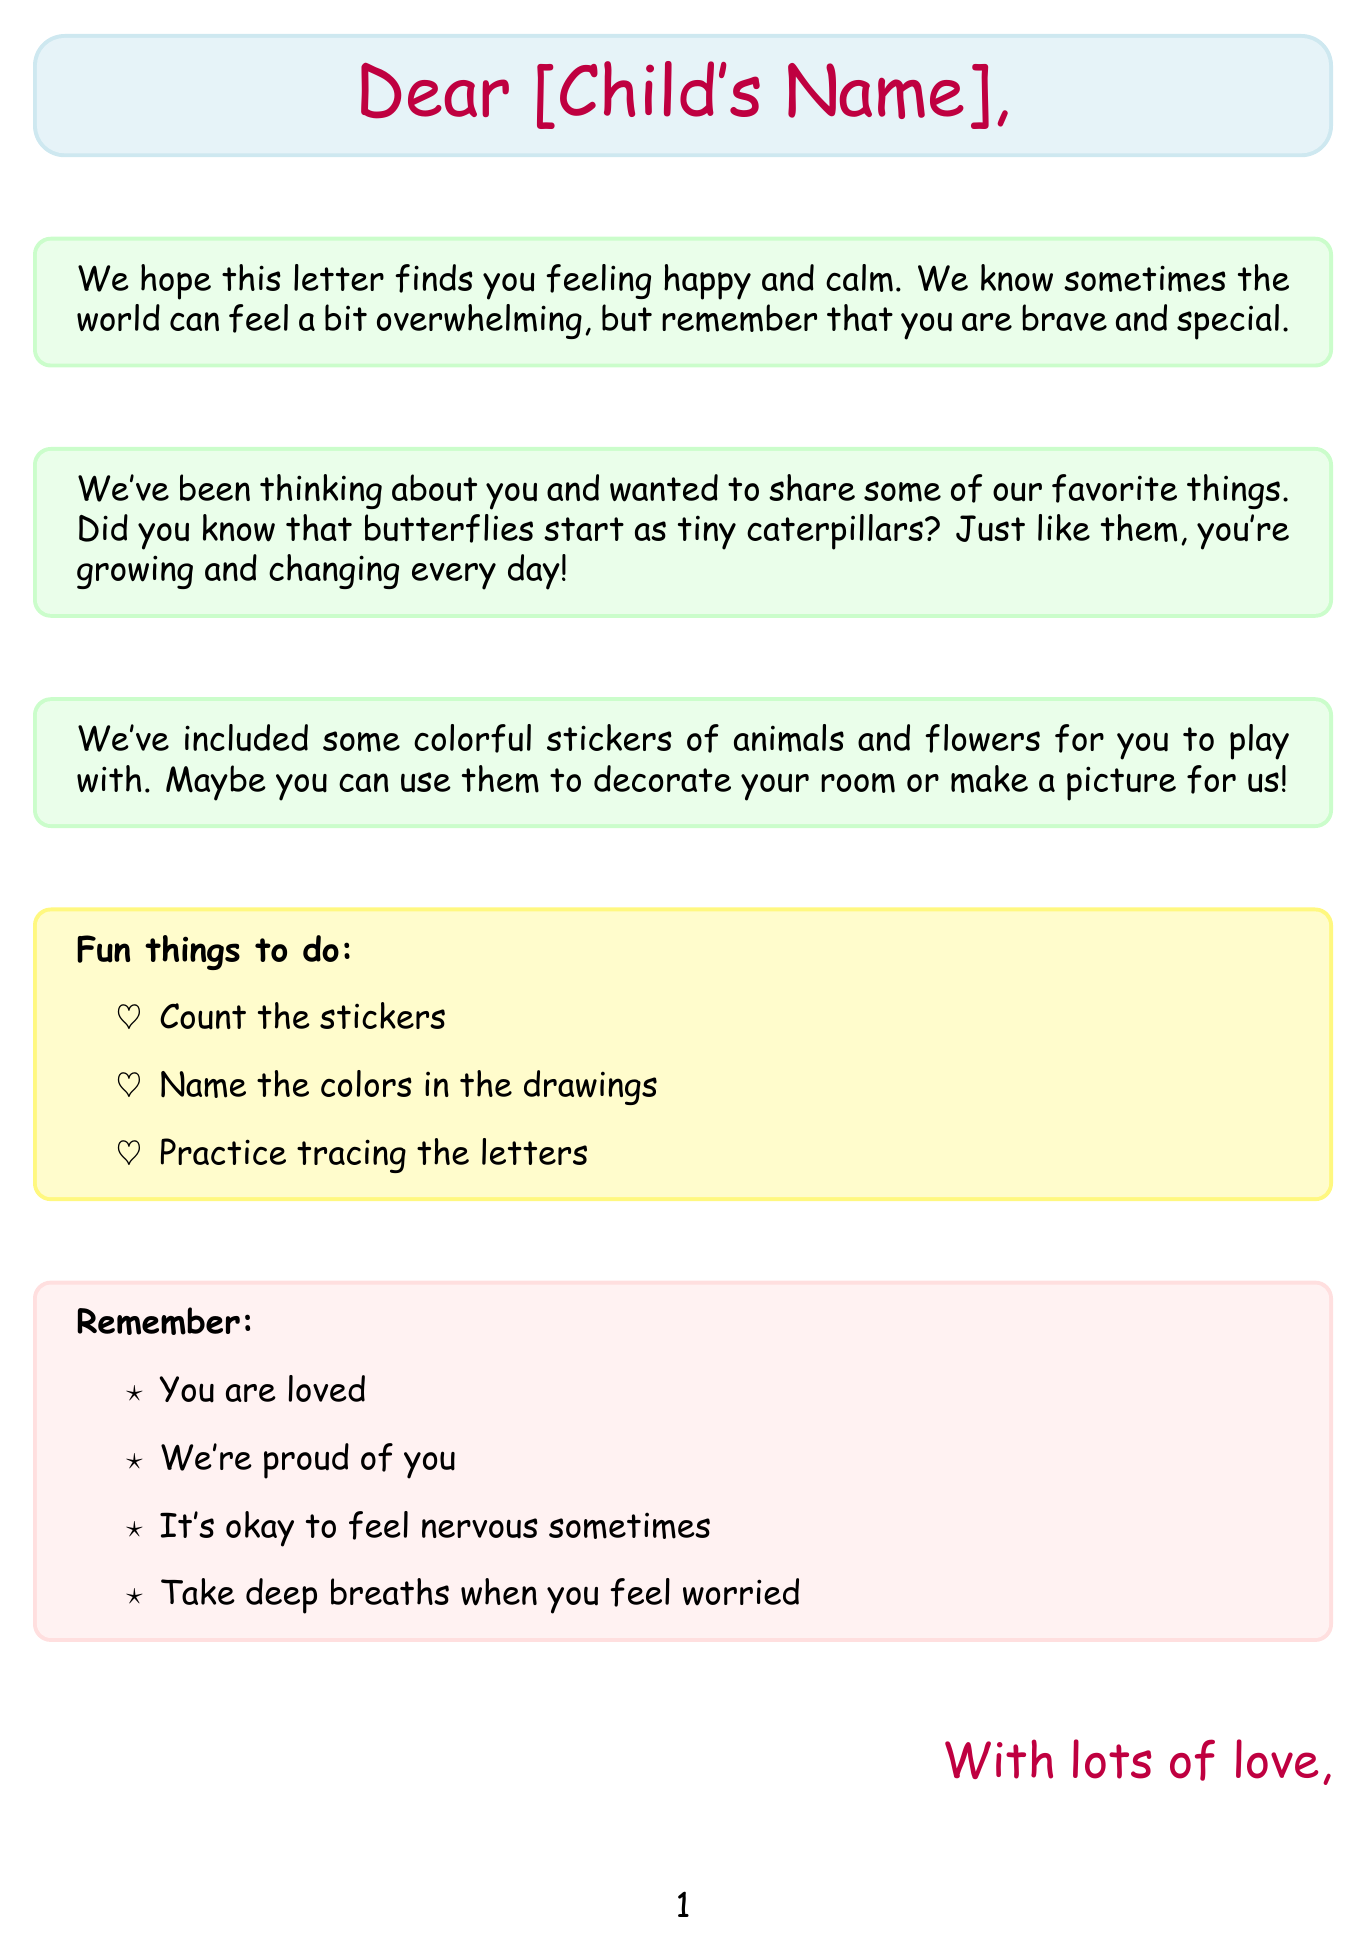what is the greeting in the letter? The greeting introduces the letter and is addressed to the child, which is "Dear [Child's Name]."
Answer: Dear [Child's Name] how many paragraphs are in the body? The body of the letter consists of three distinct paragraphs.
Answer: 3 what is the main theme in paragraph 1? Paragraph 1 expresses a message of hope and bravery amidst feelings of being overwhelmed.
Answer: happiness and bravery what kind of stickers are included in the letter? The letter mentions colorful stickers of animals and flowers, emphasizing that they're meant for play.
Answer: animals and flowers what color is the paper described in the letter? The letter describes the paper as soft and textured, highlighting its sensory qualities.
Answer: Soft, textured paper what activity is suggested to do with the stickers? The letter suggests that the child can count the stickers as one of the fun activities.
Answer: Count the stickers what kind of ink is used in the letter? The letter specifies that the ink used is lavender-scented, adding another sensory element.
Answer: scented ink (lavender) how do Grandma and Grandpa sign the letter? The closing line of the letter is signed with "Grandma and Grandpa."
Answer: Grandma and Grandpa what shape is drawn along with the letter? The letter includes a drawing of a smiley face to add a cheerful element.
Answer: smiley face 